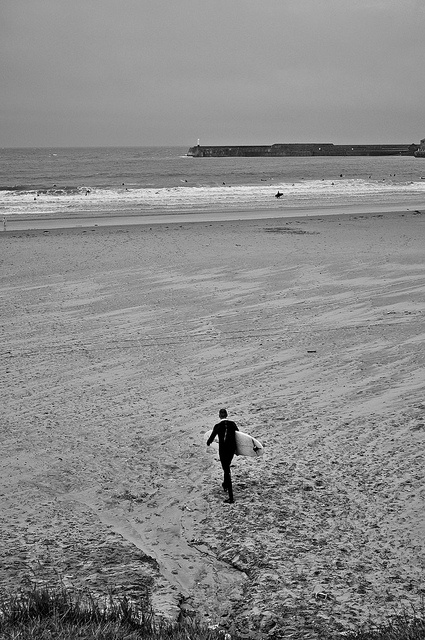Describe the objects in this image and their specific colors. I can see people in gray, black, darkgray, and gainsboro tones, surfboard in gray, darkgray, gainsboro, and black tones, people in gray and black tones, and people in gray, black, and lightgray tones in this image. 